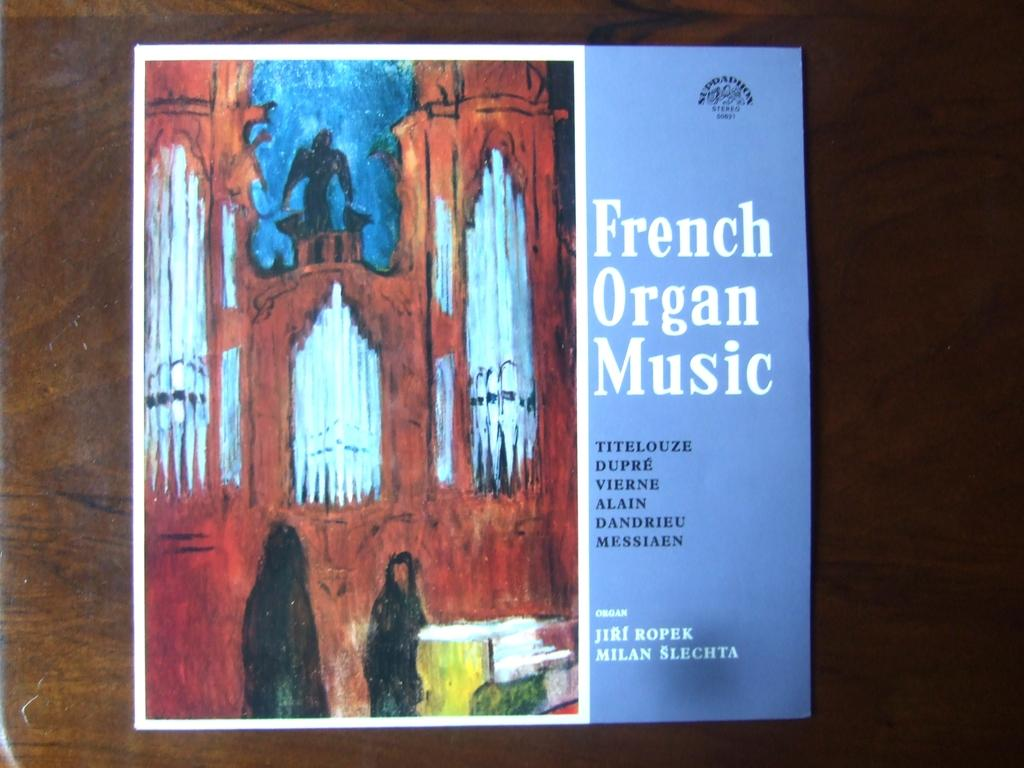<image>
Relay a brief, clear account of the picture shown. An album of French organ music features artwork of a church. 